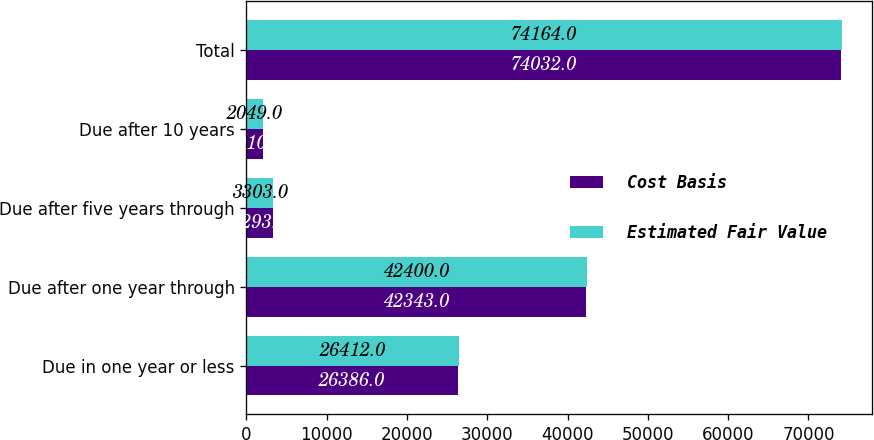<chart> <loc_0><loc_0><loc_500><loc_500><stacked_bar_chart><ecel><fcel>Due in one year or less<fcel>Due after one year through<fcel>Due after five years through<fcel>Due after 10 years<fcel>Total<nl><fcel>Cost Basis<fcel>26386<fcel>42343<fcel>3293<fcel>2010<fcel>74032<nl><fcel>Estimated Fair Value<fcel>26412<fcel>42400<fcel>3303<fcel>2049<fcel>74164<nl></chart> 